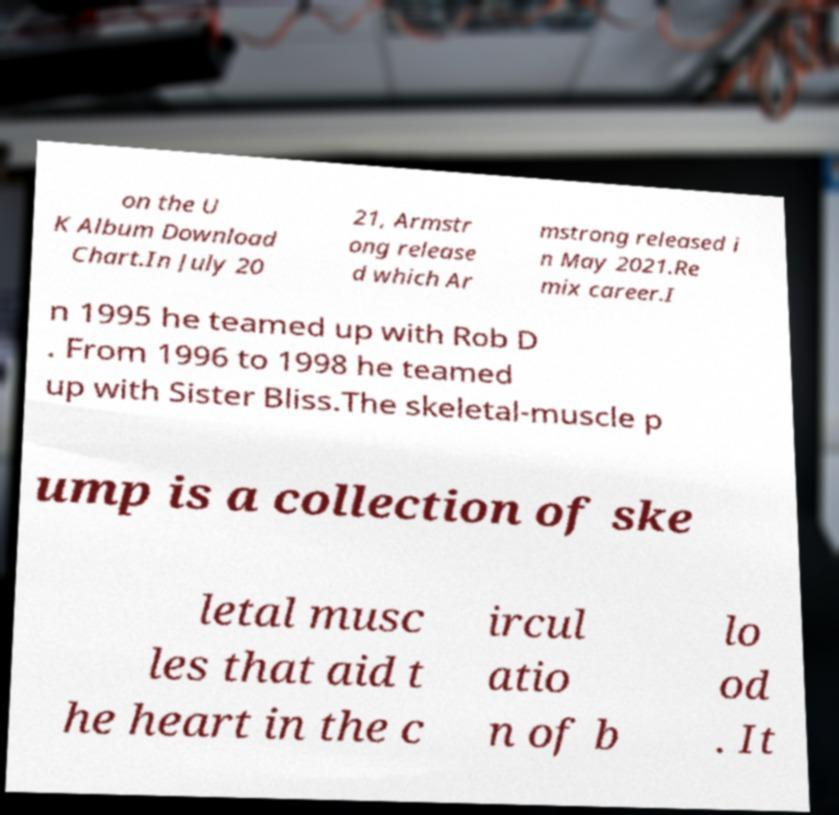For documentation purposes, I need the text within this image transcribed. Could you provide that? on the U K Album Download Chart.In July 20 21, Armstr ong release d which Ar mstrong released i n May 2021.Re mix career.I n 1995 he teamed up with Rob D . From 1996 to 1998 he teamed up with Sister Bliss.The skeletal-muscle p ump is a collection of ske letal musc les that aid t he heart in the c ircul atio n of b lo od . It 